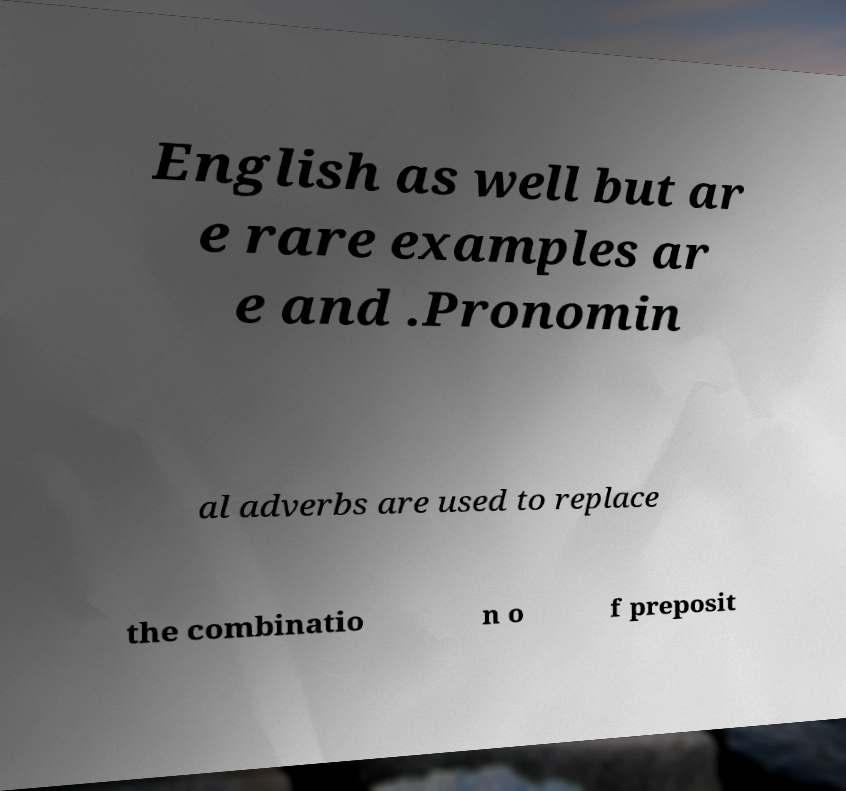Can you accurately transcribe the text from the provided image for me? English as well but ar e rare examples ar e and .Pronomin al adverbs are used to replace the combinatio n o f preposit 